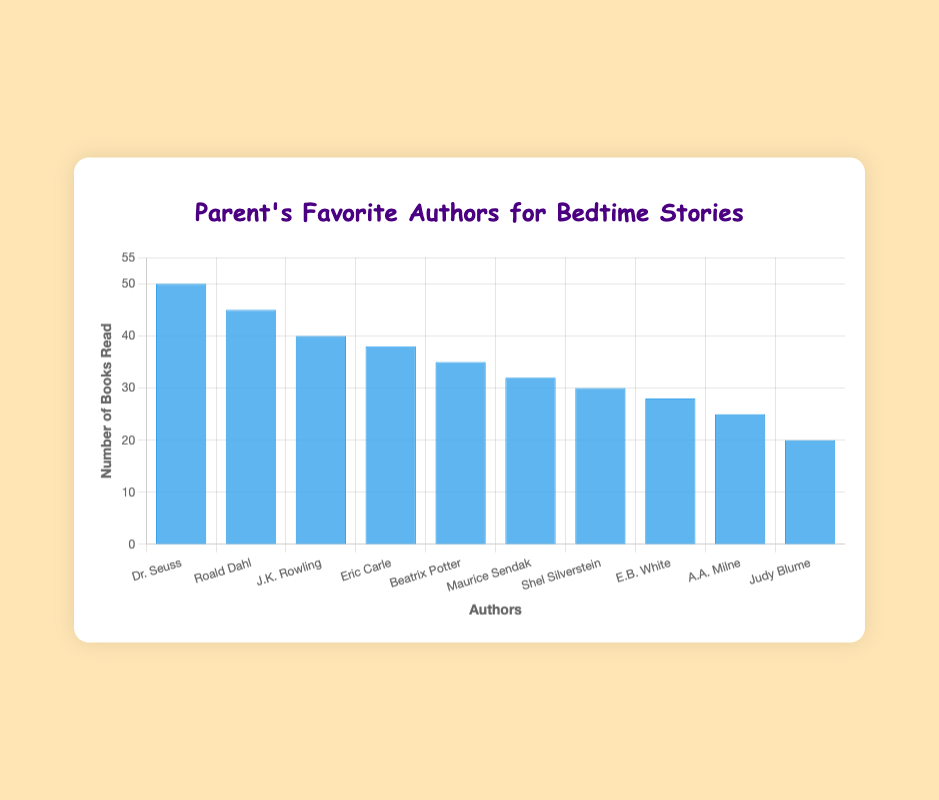Which author has the highest number of books read? Dr. Seuss has the highest bar, indicating the highest number of books read.
Answer: Dr. Seuss What is the total number of books read across all authors? Sum the values for all authors: 50 + 45 + 40 + 38 + 35 + 32 + 30 + 28 + 25 + 20 = 343.
Answer: 343 Which author has 5 more books read than Beatrix Potter? Beatrix Potter has 35 books read. Look for an author with 35 + 5 = 40 books read, which is J.K. Rowling.
Answer: J.K. Rowling On average, how many books are read per author? The total number of books read is 343, and there are 10 authors: 343 / 10 = 34.3.
Answer: 34.3 Name all authors who have read more than 30 books. Authors with more than 30 books read have bar heights above 30: Dr. Seuss (50), Roald Dahl (45), J.K. Rowling (40), Eric Carle (38), Beatrix Potter (35), Maurice Sendak (32), Shel Silverstein (30).
Answer: Dr. Seuss, Roald Dahl, J.K. Rowling, Eric Carle, Beatrix Potter, Maurice Sendak, Shel Silverstein Who read 10 more books than Eric Carle? Eric Carle has 38 books read. Look for an author with 38 + 10 = 48 books read, which matches none. So, the answer is no author.
Answer: No author What is the difference in the number of books read between the author with the most and the least books read? The author with the most books read is Dr. Seuss with 50 books, and the author with the least is Judy Blume with 20 books. The difference is 50 - 20 = 30.
Answer: 30 Which two authors have the closest number of books read to each other? Compare the differences: Roald Dahl (45) and J.K. Rowling (40) differ by 5, Eric Carle (38) and Beatrix Potter (35) differ by 3. Beatrix Potter and Maurice Sendak differ by 3. The closest is Eric Carle and Beatrix Potter, both differing by 3.
Answer: Eric Carle and Beatrix Potter What is the combined total of books read by the top three authors? The top three authors with the highest bar heights are Dr. Seuss (50), Roald Dahl (45), and J.K. Rowling (40). Sum them: 50 + 45 + 40 = 135.
Answer: 135 How many more books did Dr. Seuss read compared to Shel Silverstein? Dr. Seuss read 50 books, and Shel Silverstein read 30 books. The difference is 50 - 30 = 20.
Answer: 20 